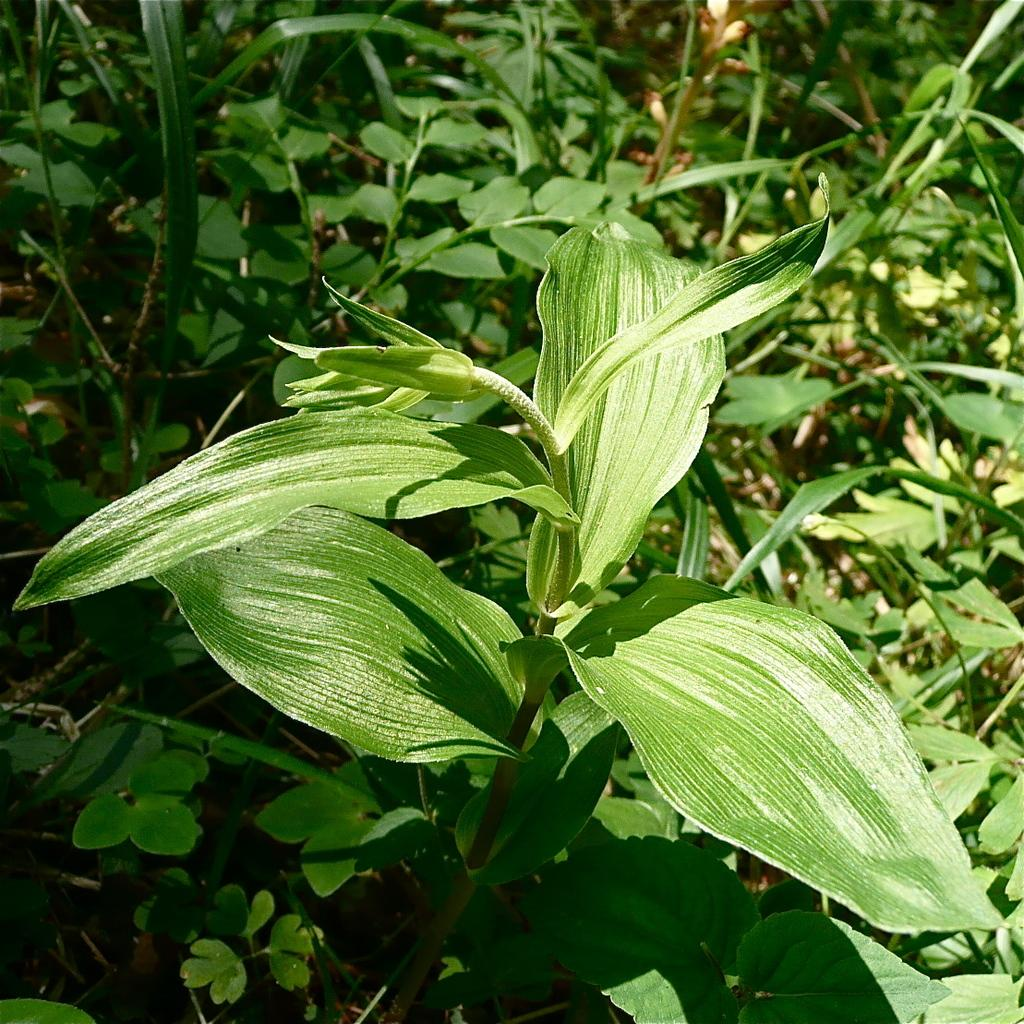What type of living organisms can be seen in the image? Plants can be seen in the image. What type of beef is being served at the home in the image? There is no home or beef present in the image; it only features plants. What is the position of the sun in the image? The provided facts do not mention the sun or its position in the image. 